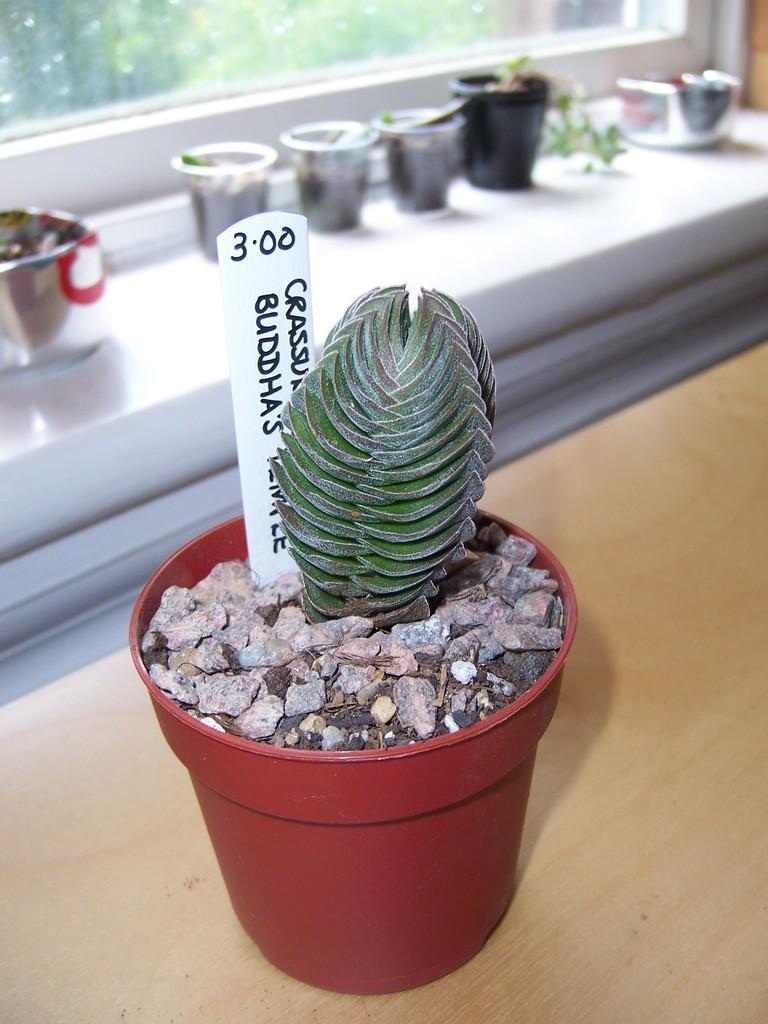Could you give a brief overview of what you see in this image? Here I can see a plant pot placed on a wooden surface. Along with plant there are few stones and a piece of paper in the pot. On the paper, I can see some text. In the background there are few other pots. At the top of the image I can see the glass. 